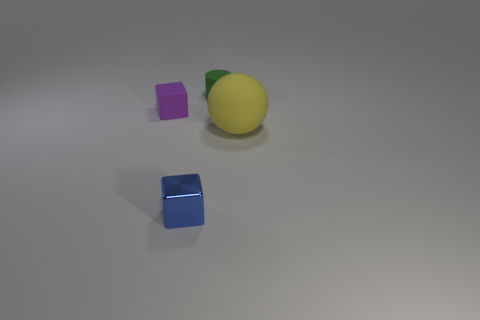Can you infer any relationships between the objects based on their placement? The objects are placed independently with no clear interaction. Their arrangement doesn't imply any specific relationships or narrative; they could represent random objects gathered for a composition exercise in a photography or a 3D modeling study. 